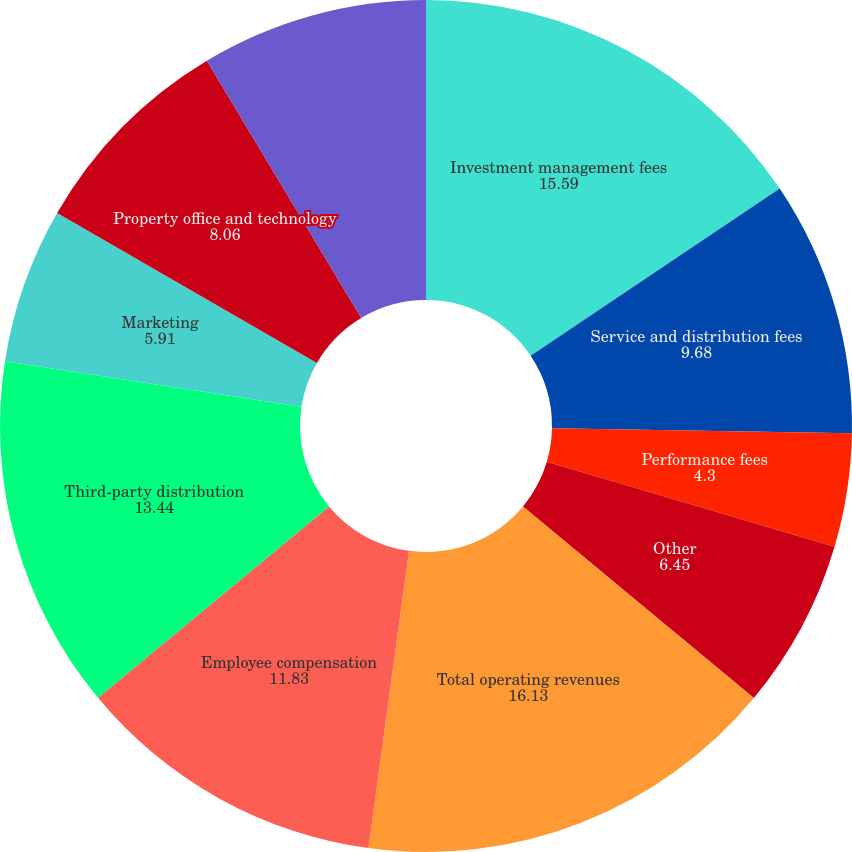Convert chart to OTSL. <chart><loc_0><loc_0><loc_500><loc_500><pie_chart><fcel>Investment management fees<fcel>Service and distribution fees<fcel>Performance fees<fcel>Other<fcel>Total operating revenues<fcel>Employee compensation<fcel>Third-party distribution<fcel>Marketing<fcel>Property office and technology<fcel>General and administrative<nl><fcel>15.59%<fcel>9.68%<fcel>4.3%<fcel>6.45%<fcel>16.13%<fcel>11.83%<fcel>13.44%<fcel>5.91%<fcel>8.06%<fcel>8.6%<nl></chart> 